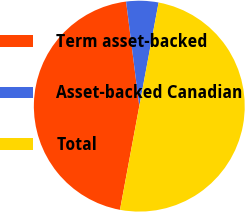Convert chart to OTSL. <chart><loc_0><loc_0><loc_500><loc_500><pie_chart><fcel>Term asset-backed<fcel>Asset-backed Canadian<fcel>Total<nl><fcel>45.07%<fcel>4.93%<fcel>50.0%<nl></chart> 